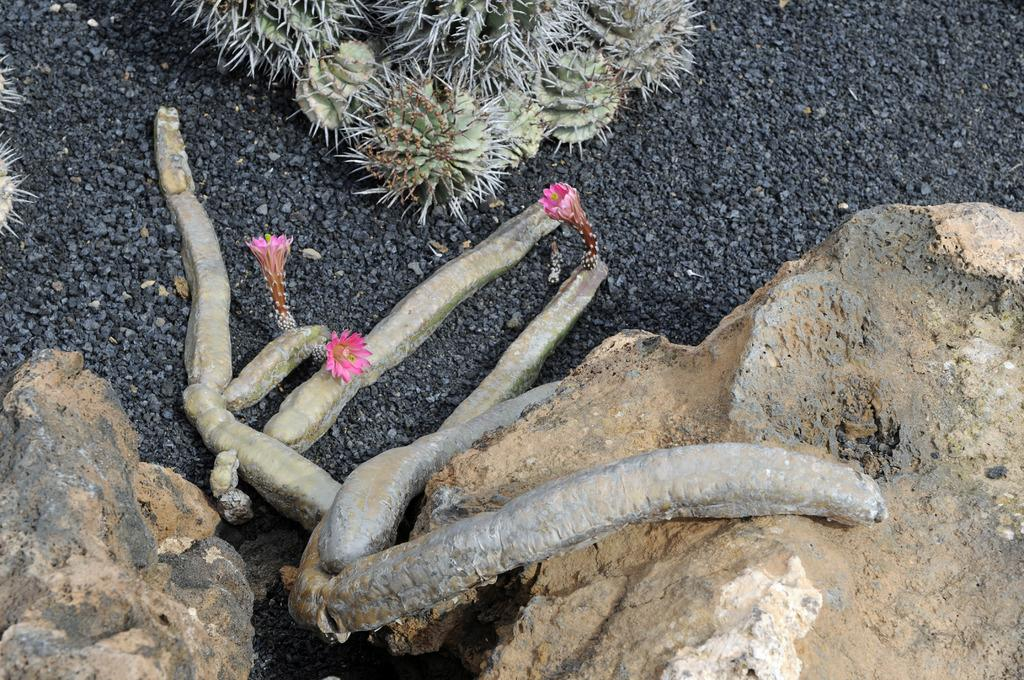What type of plants are in the image? There are cactus plants with flowers in the image. Where are the plants located? The plants are on a rocky land. What other objects can be seen in the image? There are two rocks in the front of the image. Where is the shelf located in the image? There is no shelf present in the image. Can you tell me how many knees are visible in the image? There are no knees visible in the image. 